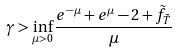Convert formula to latex. <formula><loc_0><loc_0><loc_500><loc_500>\gamma > \inf _ { \mu > 0 } \frac { e ^ { - \mu } + e ^ { \mu } - 2 + \tilde { f } _ { \tilde { T } } } { \mu }</formula> 